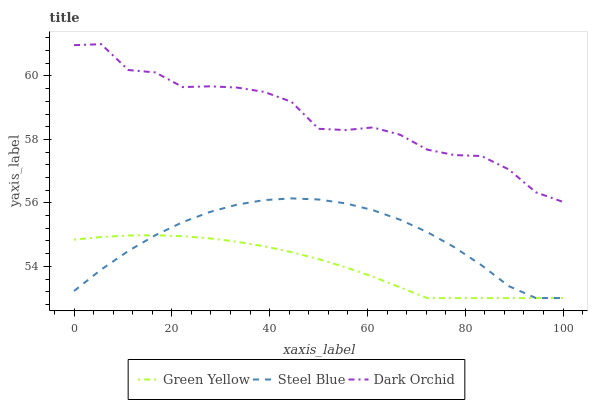Does Green Yellow have the minimum area under the curve?
Answer yes or no. Yes. Does Dark Orchid have the maximum area under the curve?
Answer yes or no. Yes. Does Steel Blue have the minimum area under the curve?
Answer yes or no. No. Does Steel Blue have the maximum area under the curve?
Answer yes or no. No. Is Green Yellow the smoothest?
Answer yes or no. Yes. Is Dark Orchid the roughest?
Answer yes or no. Yes. Is Steel Blue the smoothest?
Answer yes or no. No. Is Steel Blue the roughest?
Answer yes or no. No. Does Green Yellow have the lowest value?
Answer yes or no. Yes. Does Dark Orchid have the lowest value?
Answer yes or no. No. Does Dark Orchid have the highest value?
Answer yes or no. Yes. Does Steel Blue have the highest value?
Answer yes or no. No. Is Green Yellow less than Dark Orchid?
Answer yes or no. Yes. Is Dark Orchid greater than Steel Blue?
Answer yes or no. Yes. Does Green Yellow intersect Steel Blue?
Answer yes or no. Yes. Is Green Yellow less than Steel Blue?
Answer yes or no. No. Is Green Yellow greater than Steel Blue?
Answer yes or no. No. Does Green Yellow intersect Dark Orchid?
Answer yes or no. No. 